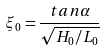<formula> <loc_0><loc_0><loc_500><loc_500>\xi _ { 0 } = \frac { t a n \alpha } { \sqrt { H _ { 0 } / L _ { 0 } } }</formula> 